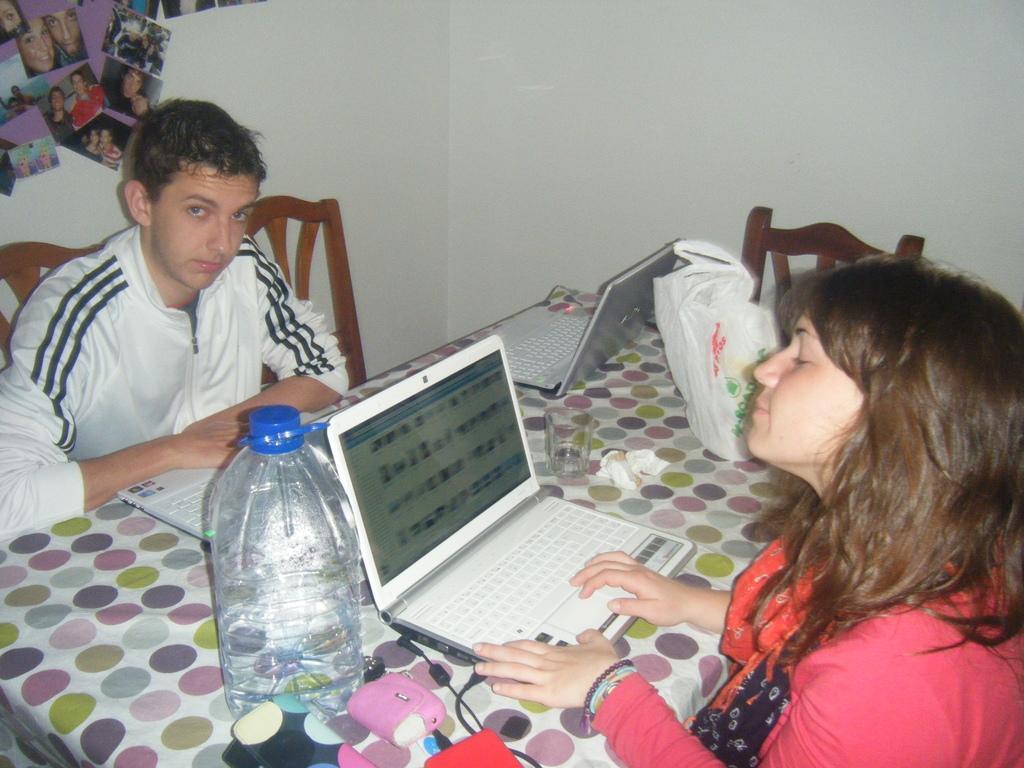How would you summarize this image in a sentence or two? In this picture we have man sitting in the chair and woman sitting in the chair and working in the laptop and the table we have water bottle,tissues, glass and then in the wall we have some photo frames. 